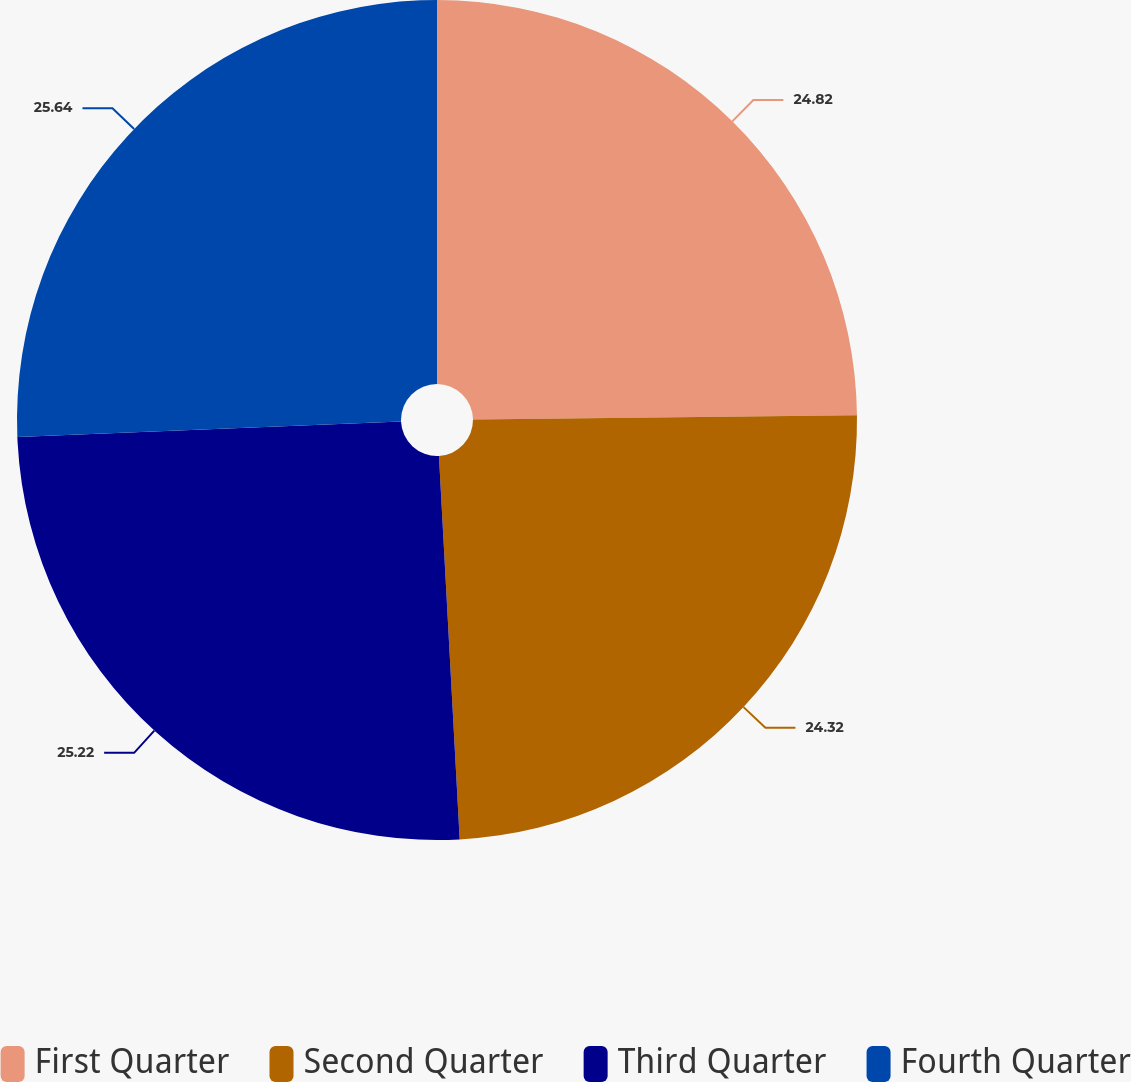Convert chart. <chart><loc_0><loc_0><loc_500><loc_500><pie_chart><fcel>First Quarter<fcel>Second Quarter<fcel>Third Quarter<fcel>Fourth Quarter<nl><fcel>24.82%<fcel>24.32%<fcel>25.22%<fcel>25.64%<nl></chart> 